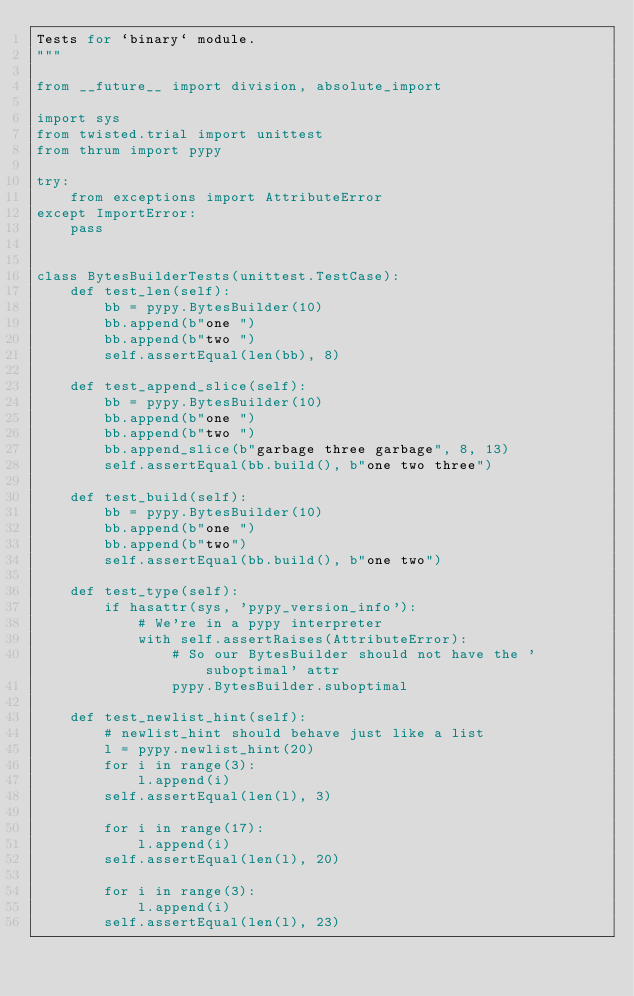Convert code to text. <code><loc_0><loc_0><loc_500><loc_500><_Python_>Tests for `binary` module.
"""

from __future__ import division, absolute_import

import sys
from twisted.trial import unittest
from thrum import pypy

try:
    from exceptions import AttributeError
except ImportError:
    pass


class BytesBuilderTests(unittest.TestCase):
    def test_len(self):
        bb = pypy.BytesBuilder(10)
        bb.append(b"one ")
        bb.append(b"two ")
        self.assertEqual(len(bb), 8)

    def test_append_slice(self):
        bb = pypy.BytesBuilder(10)
        bb.append(b"one ")
        bb.append(b"two ")
        bb.append_slice(b"garbage three garbage", 8, 13)
        self.assertEqual(bb.build(), b"one two three")

    def test_build(self):
        bb = pypy.BytesBuilder(10)
        bb.append(b"one ")
        bb.append(b"two")
        self.assertEqual(bb.build(), b"one two")

    def test_type(self):
        if hasattr(sys, 'pypy_version_info'):
            # We're in a pypy interpreter
            with self.assertRaises(AttributeError):
                # So our BytesBuilder should not have the 'suboptimal' attr
                pypy.BytesBuilder.suboptimal

    def test_newlist_hint(self):
        # newlist_hint should behave just like a list
        l = pypy.newlist_hint(20)
        for i in range(3):
            l.append(i)
        self.assertEqual(len(l), 3)

        for i in range(17):
            l.append(i)
        self.assertEqual(len(l), 20)

        for i in range(3):
            l.append(i)
        self.assertEqual(len(l), 23)
</code> 